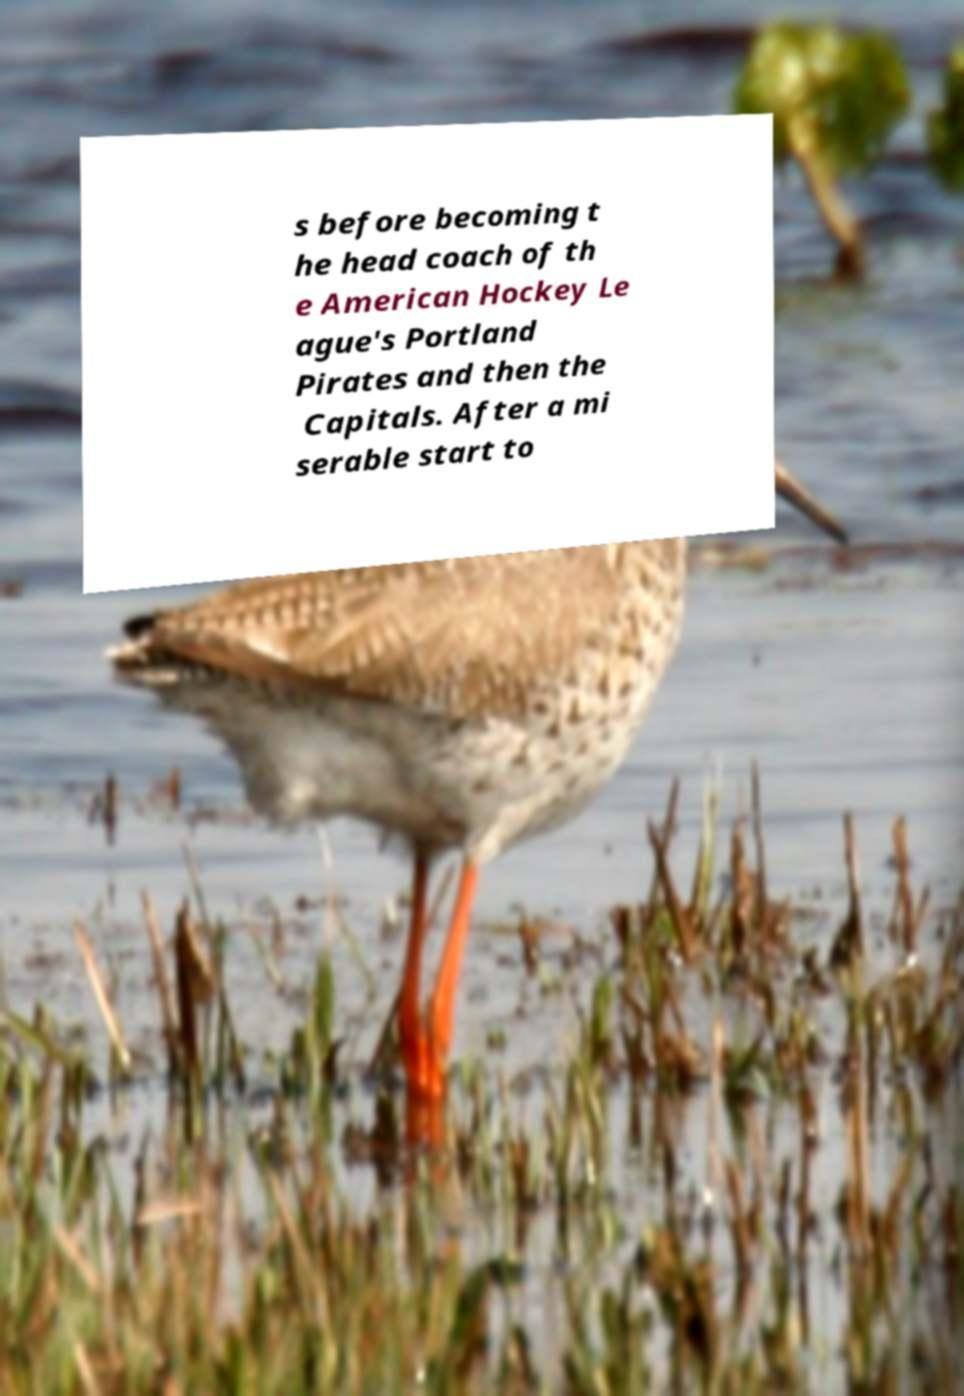Please read and relay the text visible in this image. What does it say? s before becoming t he head coach of th e American Hockey Le ague's Portland Pirates and then the Capitals. After a mi serable start to 